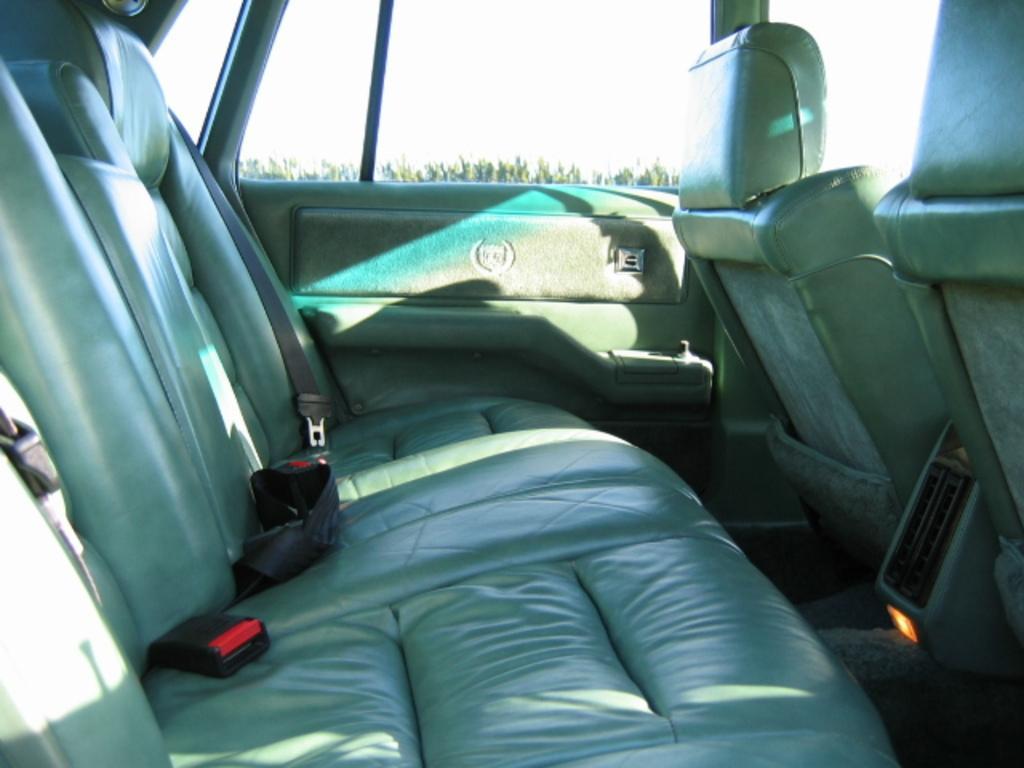Please provide a concise description of this image. This is an inside view of a car through which I can see trees and the sky. This image is taken may be during a day. 